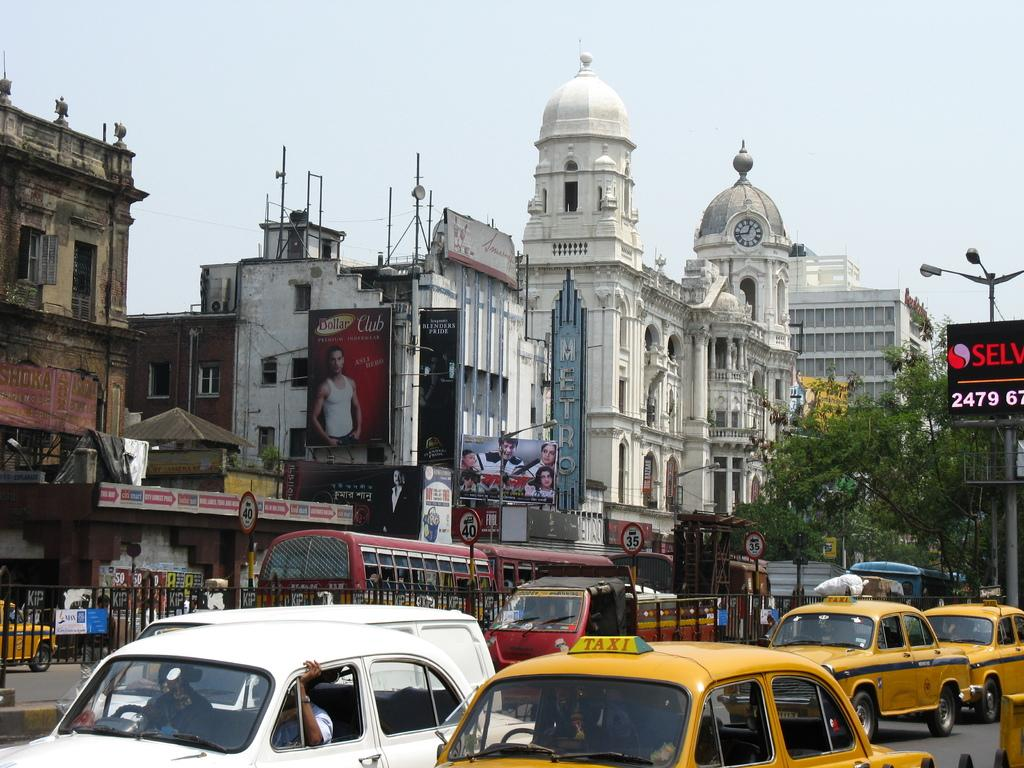Provide a one-sentence caption for the provided image. three taxi cabs are driving down a busy street. 